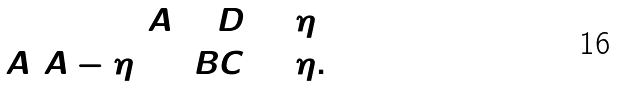<formula> <loc_0><loc_0><loc_500><loc_500>A + D & = \eta \\ A ( A - \eta ) + B C & = \eta .</formula> 